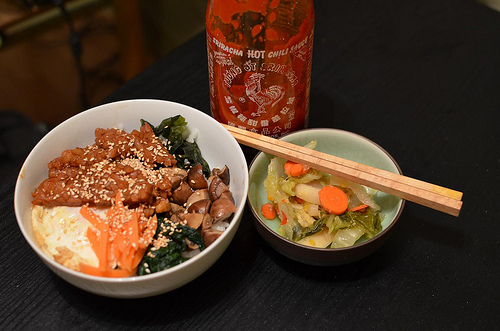<image>
Can you confirm if the food is in the bowl? No. The food is not contained within the bowl. These objects have a different spatial relationship. Is there a carrot on the table? No. The carrot is not positioned on the table. They may be near each other, but the carrot is not supported by or resting on top of the table. 